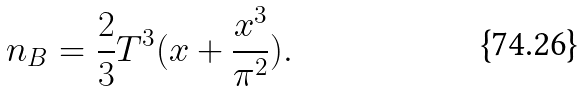<formula> <loc_0><loc_0><loc_500><loc_500>n _ { B } = \frac { 2 } { 3 } T ^ { 3 } ( x + \frac { x ^ { 3 } } { \pi ^ { 2 } } ) .</formula> 